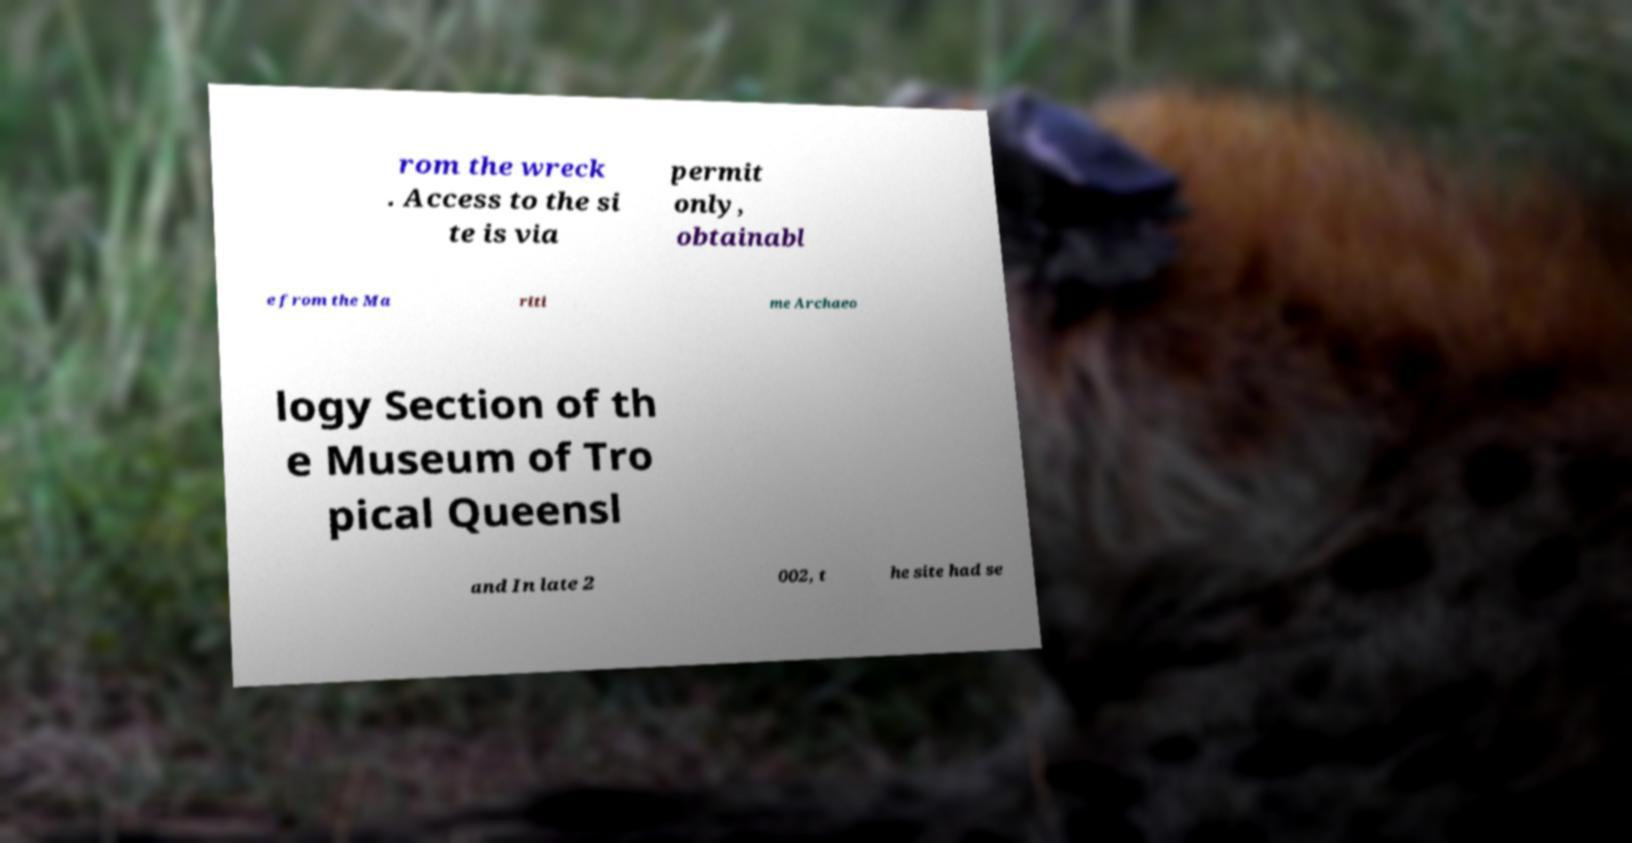What messages or text are displayed in this image? I need them in a readable, typed format. rom the wreck . Access to the si te is via permit only, obtainabl e from the Ma riti me Archaeo logy Section of th e Museum of Tro pical Queensl and In late 2 002, t he site had se 